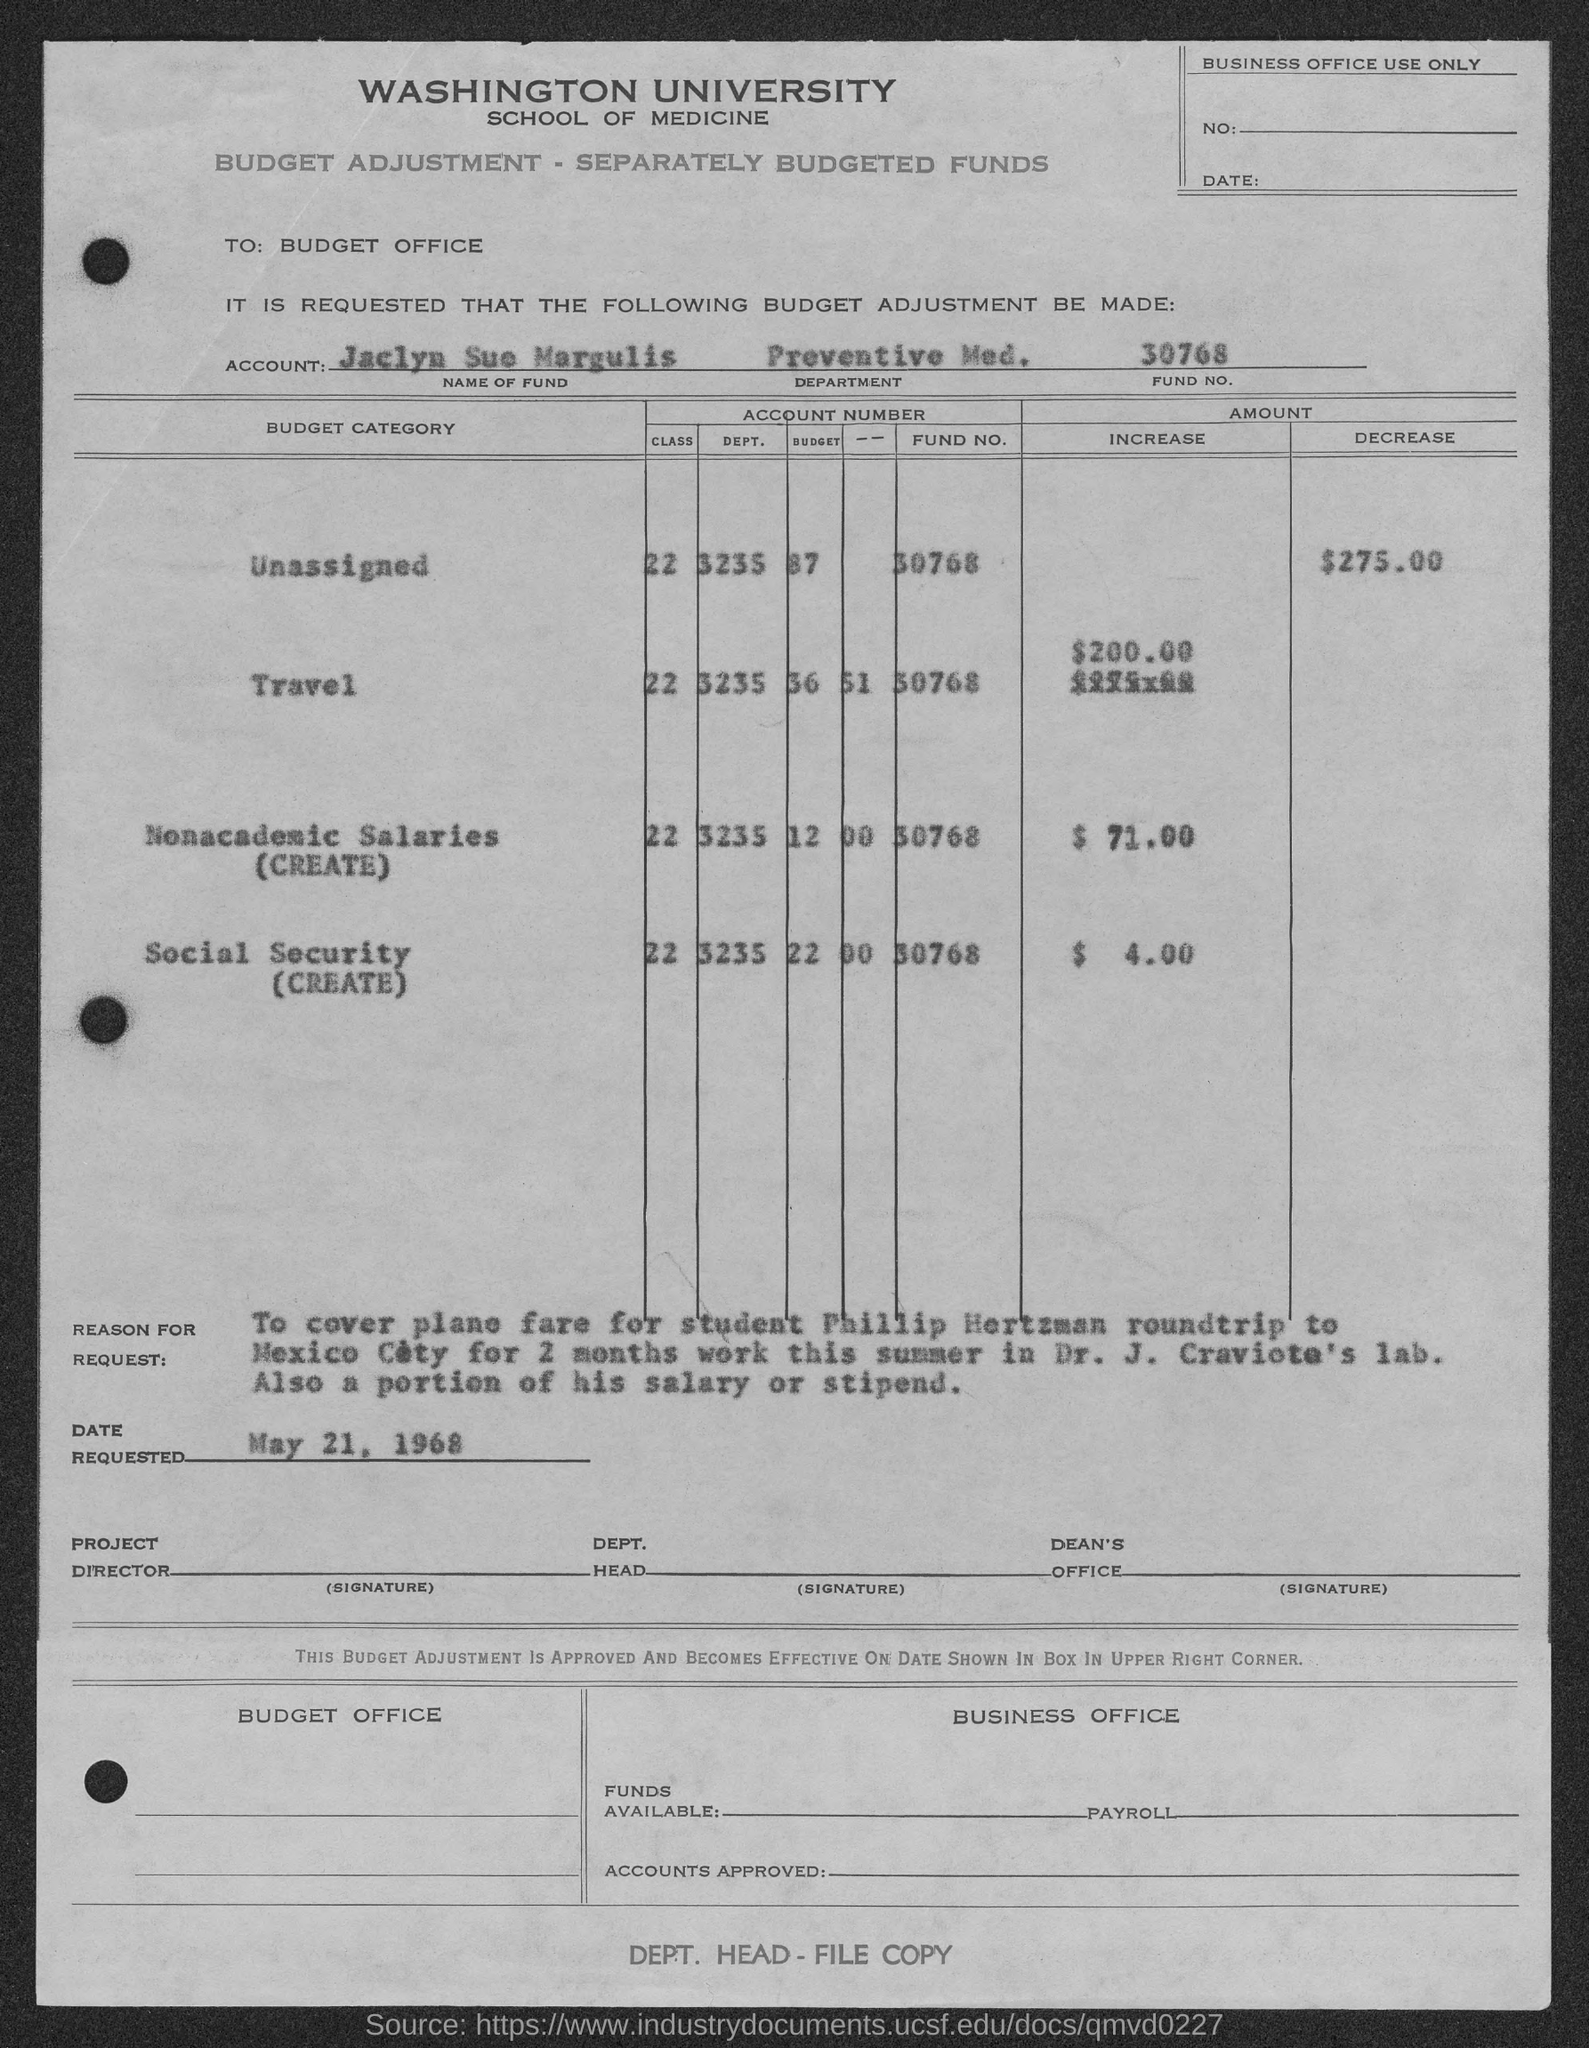Identify some key points in this picture. The amount mentioned in the given page for the increase in social security is $4.00. Can you please provide the fund number for travel mentioned in the given page? The number is 30768. The given page mentions an increase in nonacademic salaries. The date requested, as mentioned on the given page, is May 21, 1968. The travel budget mentioned in the given page does not provide the department code. 